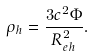<formula> <loc_0><loc_0><loc_500><loc_500>\rho _ { h } = \frac { 3 c ^ { 2 } \Phi } { R ^ { 2 } _ { e h } } .</formula> 